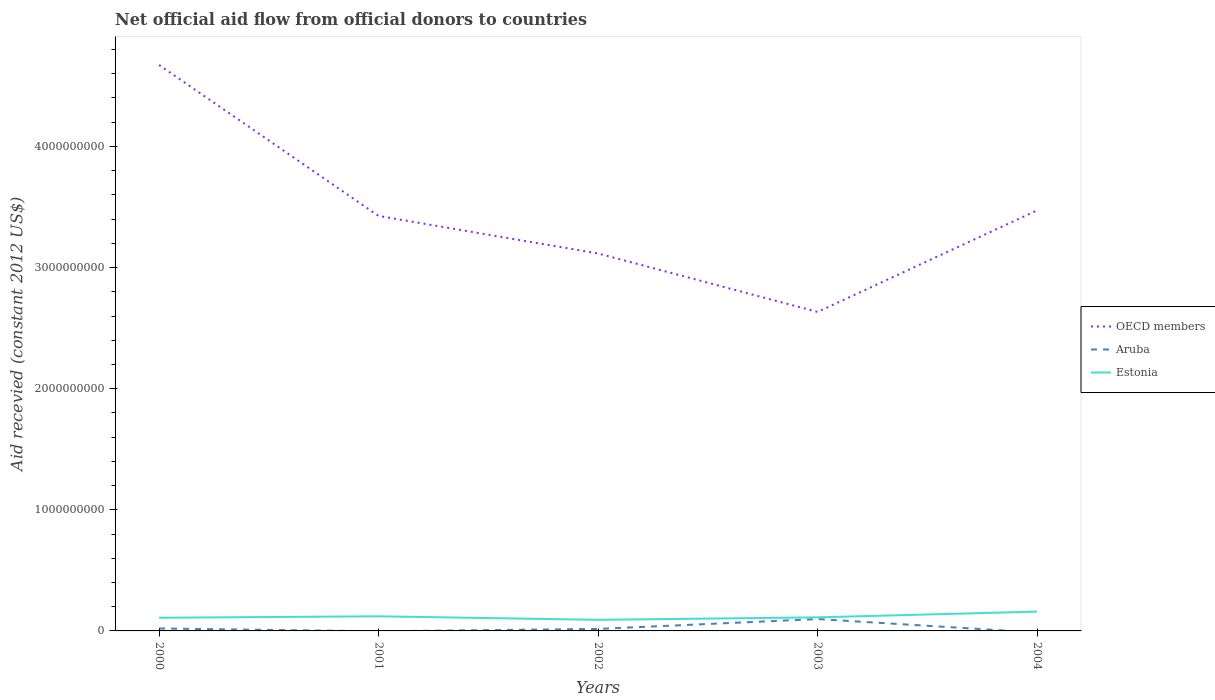Does the line corresponding to Estonia intersect with the line corresponding to OECD members?
Your answer should be very brief. No. Is the number of lines equal to the number of legend labels?
Offer a very short reply. No. What is the total total aid received in OECD members in the graph?
Your answer should be compact. -8.39e+08. What is the difference between the highest and the second highest total aid received in Aruba?
Your response must be concise. 9.79e+07. Is the total aid received in OECD members strictly greater than the total aid received in Estonia over the years?
Ensure brevity in your answer.  No. Does the graph contain grids?
Your answer should be very brief. No. Where does the legend appear in the graph?
Offer a very short reply. Center right. How are the legend labels stacked?
Your answer should be compact. Vertical. What is the title of the graph?
Ensure brevity in your answer.  Net official aid flow from official donors to countries. Does "Bosnia and Herzegovina" appear as one of the legend labels in the graph?
Ensure brevity in your answer.  No. What is the label or title of the X-axis?
Offer a very short reply. Years. What is the label or title of the Y-axis?
Ensure brevity in your answer.  Aid recevied (constant 2012 US$). What is the Aid recevied (constant 2012 US$) in OECD members in 2000?
Make the answer very short. 4.67e+09. What is the Aid recevied (constant 2012 US$) of Aruba in 2000?
Your response must be concise. 2.01e+07. What is the Aid recevied (constant 2012 US$) of Estonia in 2000?
Keep it short and to the point. 1.09e+08. What is the Aid recevied (constant 2012 US$) in OECD members in 2001?
Keep it short and to the point. 3.43e+09. What is the Aid recevied (constant 2012 US$) in Estonia in 2001?
Give a very brief answer. 1.21e+08. What is the Aid recevied (constant 2012 US$) in OECD members in 2002?
Provide a short and direct response. 3.12e+09. What is the Aid recevied (constant 2012 US$) of Aruba in 2002?
Offer a very short reply. 1.65e+07. What is the Aid recevied (constant 2012 US$) of Estonia in 2002?
Your answer should be compact. 9.16e+07. What is the Aid recevied (constant 2012 US$) of OECD members in 2003?
Offer a terse response. 2.63e+09. What is the Aid recevied (constant 2012 US$) in Aruba in 2003?
Make the answer very short. 9.79e+07. What is the Aid recevied (constant 2012 US$) of Estonia in 2003?
Provide a succinct answer. 1.12e+08. What is the Aid recevied (constant 2012 US$) in OECD members in 2004?
Offer a terse response. 3.47e+09. What is the Aid recevied (constant 2012 US$) of Aruba in 2004?
Ensure brevity in your answer.  0. What is the Aid recevied (constant 2012 US$) of Estonia in 2004?
Your answer should be compact. 1.59e+08. Across all years, what is the maximum Aid recevied (constant 2012 US$) in OECD members?
Offer a terse response. 4.67e+09. Across all years, what is the maximum Aid recevied (constant 2012 US$) in Aruba?
Offer a very short reply. 9.79e+07. Across all years, what is the maximum Aid recevied (constant 2012 US$) in Estonia?
Make the answer very short. 1.59e+08. Across all years, what is the minimum Aid recevied (constant 2012 US$) of OECD members?
Keep it short and to the point. 2.63e+09. Across all years, what is the minimum Aid recevied (constant 2012 US$) of Aruba?
Provide a short and direct response. 0. Across all years, what is the minimum Aid recevied (constant 2012 US$) in Estonia?
Keep it short and to the point. 9.16e+07. What is the total Aid recevied (constant 2012 US$) of OECD members in the graph?
Your answer should be compact. 1.73e+1. What is the total Aid recevied (constant 2012 US$) of Aruba in the graph?
Provide a short and direct response. 1.35e+08. What is the total Aid recevied (constant 2012 US$) in Estonia in the graph?
Ensure brevity in your answer.  5.93e+08. What is the difference between the Aid recevied (constant 2012 US$) of OECD members in 2000 and that in 2001?
Give a very brief answer. 1.25e+09. What is the difference between the Aid recevied (constant 2012 US$) in Estonia in 2000 and that in 2001?
Offer a terse response. -1.20e+07. What is the difference between the Aid recevied (constant 2012 US$) of OECD members in 2000 and that in 2002?
Provide a short and direct response. 1.56e+09. What is the difference between the Aid recevied (constant 2012 US$) of Aruba in 2000 and that in 2002?
Your answer should be very brief. 3.62e+06. What is the difference between the Aid recevied (constant 2012 US$) in Estonia in 2000 and that in 2002?
Keep it short and to the point. 1.71e+07. What is the difference between the Aid recevied (constant 2012 US$) of OECD members in 2000 and that in 2003?
Offer a terse response. 2.04e+09. What is the difference between the Aid recevied (constant 2012 US$) in Aruba in 2000 and that in 2003?
Your response must be concise. -7.78e+07. What is the difference between the Aid recevied (constant 2012 US$) of Estonia in 2000 and that in 2003?
Provide a short and direct response. -3.35e+06. What is the difference between the Aid recevied (constant 2012 US$) of OECD members in 2000 and that in 2004?
Provide a short and direct response. 1.20e+09. What is the difference between the Aid recevied (constant 2012 US$) of Estonia in 2000 and that in 2004?
Your answer should be compact. -5.08e+07. What is the difference between the Aid recevied (constant 2012 US$) in OECD members in 2001 and that in 2002?
Provide a succinct answer. 3.10e+08. What is the difference between the Aid recevied (constant 2012 US$) of Estonia in 2001 and that in 2002?
Provide a short and direct response. 2.91e+07. What is the difference between the Aid recevied (constant 2012 US$) in OECD members in 2001 and that in 2003?
Provide a short and direct response. 7.93e+08. What is the difference between the Aid recevied (constant 2012 US$) in Estonia in 2001 and that in 2003?
Provide a succinct answer. 8.66e+06. What is the difference between the Aid recevied (constant 2012 US$) of OECD members in 2001 and that in 2004?
Ensure brevity in your answer.  -4.60e+07. What is the difference between the Aid recevied (constant 2012 US$) in Estonia in 2001 and that in 2004?
Give a very brief answer. -3.88e+07. What is the difference between the Aid recevied (constant 2012 US$) of OECD members in 2002 and that in 2003?
Keep it short and to the point. 4.83e+08. What is the difference between the Aid recevied (constant 2012 US$) of Aruba in 2002 and that in 2003?
Make the answer very short. -8.14e+07. What is the difference between the Aid recevied (constant 2012 US$) in Estonia in 2002 and that in 2003?
Offer a terse response. -2.05e+07. What is the difference between the Aid recevied (constant 2012 US$) of OECD members in 2002 and that in 2004?
Offer a very short reply. -3.56e+08. What is the difference between the Aid recevied (constant 2012 US$) in Estonia in 2002 and that in 2004?
Offer a terse response. -6.79e+07. What is the difference between the Aid recevied (constant 2012 US$) of OECD members in 2003 and that in 2004?
Offer a terse response. -8.39e+08. What is the difference between the Aid recevied (constant 2012 US$) in Estonia in 2003 and that in 2004?
Provide a succinct answer. -4.74e+07. What is the difference between the Aid recevied (constant 2012 US$) in OECD members in 2000 and the Aid recevied (constant 2012 US$) in Estonia in 2001?
Give a very brief answer. 4.55e+09. What is the difference between the Aid recevied (constant 2012 US$) in Aruba in 2000 and the Aid recevied (constant 2012 US$) in Estonia in 2001?
Make the answer very short. -1.01e+08. What is the difference between the Aid recevied (constant 2012 US$) of OECD members in 2000 and the Aid recevied (constant 2012 US$) of Aruba in 2002?
Your answer should be compact. 4.66e+09. What is the difference between the Aid recevied (constant 2012 US$) in OECD members in 2000 and the Aid recevied (constant 2012 US$) in Estonia in 2002?
Provide a succinct answer. 4.58e+09. What is the difference between the Aid recevied (constant 2012 US$) in Aruba in 2000 and the Aid recevied (constant 2012 US$) in Estonia in 2002?
Offer a terse response. -7.15e+07. What is the difference between the Aid recevied (constant 2012 US$) in OECD members in 2000 and the Aid recevied (constant 2012 US$) in Aruba in 2003?
Your answer should be very brief. 4.57e+09. What is the difference between the Aid recevied (constant 2012 US$) in OECD members in 2000 and the Aid recevied (constant 2012 US$) in Estonia in 2003?
Keep it short and to the point. 4.56e+09. What is the difference between the Aid recevied (constant 2012 US$) of Aruba in 2000 and the Aid recevied (constant 2012 US$) of Estonia in 2003?
Keep it short and to the point. -9.20e+07. What is the difference between the Aid recevied (constant 2012 US$) in OECD members in 2000 and the Aid recevied (constant 2012 US$) in Estonia in 2004?
Make the answer very short. 4.51e+09. What is the difference between the Aid recevied (constant 2012 US$) of Aruba in 2000 and the Aid recevied (constant 2012 US$) of Estonia in 2004?
Provide a short and direct response. -1.39e+08. What is the difference between the Aid recevied (constant 2012 US$) of OECD members in 2001 and the Aid recevied (constant 2012 US$) of Aruba in 2002?
Keep it short and to the point. 3.41e+09. What is the difference between the Aid recevied (constant 2012 US$) of OECD members in 2001 and the Aid recevied (constant 2012 US$) of Estonia in 2002?
Your answer should be compact. 3.33e+09. What is the difference between the Aid recevied (constant 2012 US$) of OECD members in 2001 and the Aid recevied (constant 2012 US$) of Aruba in 2003?
Offer a terse response. 3.33e+09. What is the difference between the Aid recevied (constant 2012 US$) of OECD members in 2001 and the Aid recevied (constant 2012 US$) of Estonia in 2003?
Offer a very short reply. 3.31e+09. What is the difference between the Aid recevied (constant 2012 US$) in OECD members in 2001 and the Aid recevied (constant 2012 US$) in Estonia in 2004?
Provide a succinct answer. 3.27e+09. What is the difference between the Aid recevied (constant 2012 US$) in OECD members in 2002 and the Aid recevied (constant 2012 US$) in Aruba in 2003?
Ensure brevity in your answer.  3.02e+09. What is the difference between the Aid recevied (constant 2012 US$) of OECD members in 2002 and the Aid recevied (constant 2012 US$) of Estonia in 2003?
Offer a terse response. 3.00e+09. What is the difference between the Aid recevied (constant 2012 US$) in Aruba in 2002 and the Aid recevied (constant 2012 US$) in Estonia in 2003?
Provide a short and direct response. -9.56e+07. What is the difference between the Aid recevied (constant 2012 US$) in OECD members in 2002 and the Aid recevied (constant 2012 US$) in Estonia in 2004?
Keep it short and to the point. 2.96e+09. What is the difference between the Aid recevied (constant 2012 US$) of Aruba in 2002 and the Aid recevied (constant 2012 US$) of Estonia in 2004?
Offer a terse response. -1.43e+08. What is the difference between the Aid recevied (constant 2012 US$) of OECD members in 2003 and the Aid recevied (constant 2012 US$) of Estonia in 2004?
Provide a short and direct response. 2.47e+09. What is the difference between the Aid recevied (constant 2012 US$) in Aruba in 2003 and the Aid recevied (constant 2012 US$) in Estonia in 2004?
Your answer should be very brief. -6.16e+07. What is the average Aid recevied (constant 2012 US$) in OECD members per year?
Provide a succinct answer. 3.46e+09. What is the average Aid recevied (constant 2012 US$) of Aruba per year?
Provide a succinct answer. 2.69e+07. What is the average Aid recevied (constant 2012 US$) of Estonia per year?
Provide a short and direct response. 1.19e+08. In the year 2000, what is the difference between the Aid recevied (constant 2012 US$) in OECD members and Aid recevied (constant 2012 US$) in Aruba?
Give a very brief answer. 4.65e+09. In the year 2000, what is the difference between the Aid recevied (constant 2012 US$) of OECD members and Aid recevied (constant 2012 US$) of Estonia?
Offer a very short reply. 4.56e+09. In the year 2000, what is the difference between the Aid recevied (constant 2012 US$) in Aruba and Aid recevied (constant 2012 US$) in Estonia?
Your answer should be very brief. -8.86e+07. In the year 2001, what is the difference between the Aid recevied (constant 2012 US$) in OECD members and Aid recevied (constant 2012 US$) in Estonia?
Your answer should be compact. 3.31e+09. In the year 2002, what is the difference between the Aid recevied (constant 2012 US$) of OECD members and Aid recevied (constant 2012 US$) of Aruba?
Your answer should be compact. 3.10e+09. In the year 2002, what is the difference between the Aid recevied (constant 2012 US$) of OECD members and Aid recevied (constant 2012 US$) of Estonia?
Your answer should be very brief. 3.02e+09. In the year 2002, what is the difference between the Aid recevied (constant 2012 US$) of Aruba and Aid recevied (constant 2012 US$) of Estonia?
Provide a succinct answer. -7.51e+07. In the year 2003, what is the difference between the Aid recevied (constant 2012 US$) of OECD members and Aid recevied (constant 2012 US$) of Aruba?
Your response must be concise. 2.54e+09. In the year 2003, what is the difference between the Aid recevied (constant 2012 US$) in OECD members and Aid recevied (constant 2012 US$) in Estonia?
Ensure brevity in your answer.  2.52e+09. In the year 2003, what is the difference between the Aid recevied (constant 2012 US$) in Aruba and Aid recevied (constant 2012 US$) in Estonia?
Your answer should be compact. -1.42e+07. In the year 2004, what is the difference between the Aid recevied (constant 2012 US$) of OECD members and Aid recevied (constant 2012 US$) of Estonia?
Keep it short and to the point. 3.31e+09. What is the ratio of the Aid recevied (constant 2012 US$) of OECD members in 2000 to that in 2001?
Your response must be concise. 1.36. What is the ratio of the Aid recevied (constant 2012 US$) of Estonia in 2000 to that in 2001?
Make the answer very short. 0.9. What is the ratio of the Aid recevied (constant 2012 US$) in OECD members in 2000 to that in 2002?
Your answer should be compact. 1.5. What is the ratio of the Aid recevied (constant 2012 US$) of Aruba in 2000 to that in 2002?
Keep it short and to the point. 1.22. What is the ratio of the Aid recevied (constant 2012 US$) in Estonia in 2000 to that in 2002?
Make the answer very short. 1.19. What is the ratio of the Aid recevied (constant 2012 US$) in OECD members in 2000 to that in 2003?
Keep it short and to the point. 1.77. What is the ratio of the Aid recevied (constant 2012 US$) of Aruba in 2000 to that in 2003?
Keep it short and to the point. 0.21. What is the ratio of the Aid recevied (constant 2012 US$) in Estonia in 2000 to that in 2003?
Make the answer very short. 0.97. What is the ratio of the Aid recevied (constant 2012 US$) in OECD members in 2000 to that in 2004?
Make the answer very short. 1.35. What is the ratio of the Aid recevied (constant 2012 US$) of Estonia in 2000 to that in 2004?
Offer a terse response. 0.68. What is the ratio of the Aid recevied (constant 2012 US$) in OECD members in 2001 to that in 2002?
Provide a short and direct response. 1.1. What is the ratio of the Aid recevied (constant 2012 US$) in Estonia in 2001 to that in 2002?
Ensure brevity in your answer.  1.32. What is the ratio of the Aid recevied (constant 2012 US$) of OECD members in 2001 to that in 2003?
Make the answer very short. 1.3. What is the ratio of the Aid recevied (constant 2012 US$) in Estonia in 2001 to that in 2003?
Keep it short and to the point. 1.08. What is the ratio of the Aid recevied (constant 2012 US$) in OECD members in 2001 to that in 2004?
Offer a terse response. 0.99. What is the ratio of the Aid recevied (constant 2012 US$) of Estonia in 2001 to that in 2004?
Ensure brevity in your answer.  0.76. What is the ratio of the Aid recevied (constant 2012 US$) in OECD members in 2002 to that in 2003?
Offer a very short reply. 1.18. What is the ratio of the Aid recevied (constant 2012 US$) in Aruba in 2002 to that in 2003?
Offer a terse response. 0.17. What is the ratio of the Aid recevied (constant 2012 US$) in Estonia in 2002 to that in 2003?
Ensure brevity in your answer.  0.82. What is the ratio of the Aid recevied (constant 2012 US$) in OECD members in 2002 to that in 2004?
Ensure brevity in your answer.  0.9. What is the ratio of the Aid recevied (constant 2012 US$) in Estonia in 2002 to that in 2004?
Give a very brief answer. 0.57. What is the ratio of the Aid recevied (constant 2012 US$) of OECD members in 2003 to that in 2004?
Your answer should be compact. 0.76. What is the ratio of the Aid recevied (constant 2012 US$) in Estonia in 2003 to that in 2004?
Provide a short and direct response. 0.7. What is the difference between the highest and the second highest Aid recevied (constant 2012 US$) in OECD members?
Offer a very short reply. 1.20e+09. What is the difference between the highest and the second highest Aid recevied (constant 2012 US$) in Aruba?
Offer a very short reply. 7.78e+07. What is the difference between the highest and the second highest Aid recevied (constant 2012 US$) in Estonia?
Your answer should be very brief. 3.88e+07. What is the difference between the highest and the lowest Aid recevied (constant 2012 US$) of OECD members?
Give a very brief answer. 2.04e+09. What is the difference between the highest and the lowest Aid recevied (constant 2012 US$) in Aruba?
Your response must be concise. 9.79e+07. What is the difference between the highest and the lowest Aid recevied (constant 2012 US$) in Estonia?
Provide a short and direct response. 6.79e+07. 